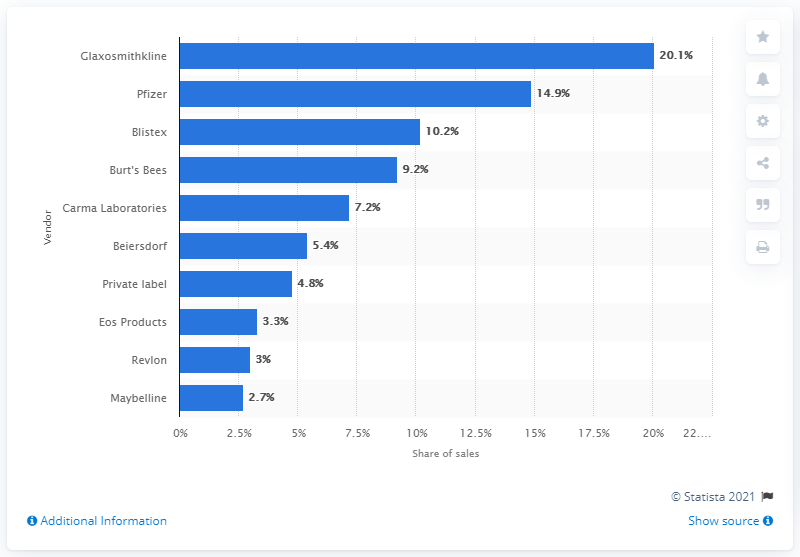Specify some key components in this picture. In 2012, Glaxosmithkline was the leading vendor of lip balm and cold sore medication in the United States. 